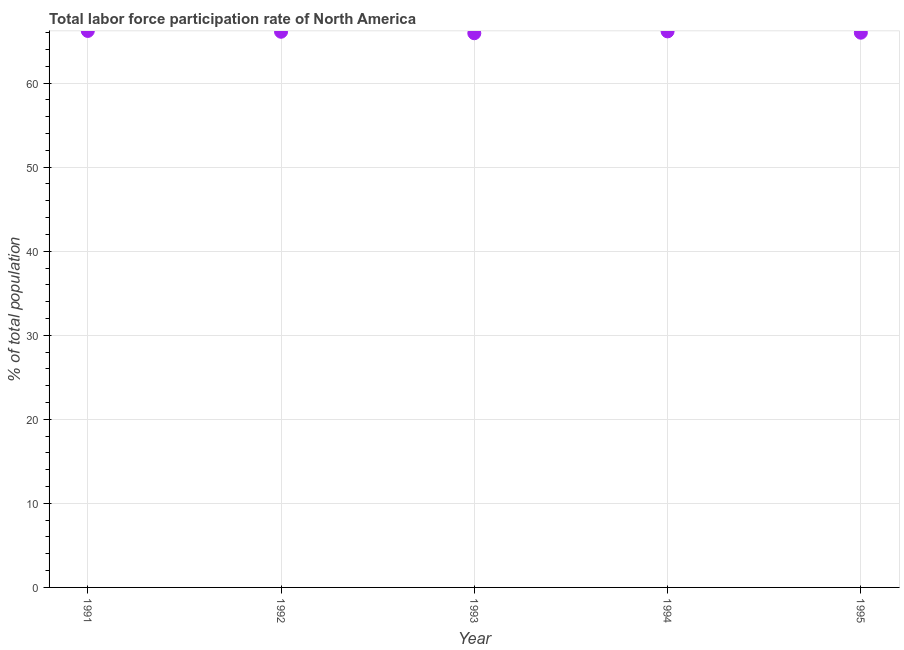What is the total labor force participation rate in 1994?
Provide a short and direct response. 66.15. Across all years, what is the maximum total labor force participation rate?
Your response must be concise. 66.21. Across all years, what is the minimum total labor force participation rate?
Ensure brevity in your answer.  65.93. In which year was the total labor force participation rate minimum?
Offer a terse response. 1993. What is the sum of the total labor force participation rate?
Ensure brevity in your answer.  330.4. What is the difference between the total labor force participation rate in 1991 and 1992?
Offer a very short reply. 0.1. What is the average total labor force participation rate per year?
Your answer should be compact. 66.08. What is the median total labor force participation rate?
Keep it short and to the point. 66.11. In how many years, is the total labor force participation rate greater than 12 %?
Provide a short and direct response. 5. Do a majority of the years between 1993 and 1994 (inclusive) have total labor force participation rate greater than 58 %?
Provide a succinct answer. Yes. What is the ratio of the total labor force participation rate in 1994 to that in 1995?
Your answer should be very brief. 1. What is the difference between the highest and the second highest total labor force participation rate?
Your answer should be compact. 0.05. Is the sum of the total labor force participation rate in 1991 and 1995 greater than the maximum total labor force participation rate across all years?
Keep it short and to the point. Yes. What is the difference between the highest and the lowest total labor force participation rate?
Offer a very short reply. 0.27. In how many years, is the total labor force participation rate greater than the average total labor force participation rate taken over all years?
Offer a terse response. 3. How many dotlines are there?
Provide a succinct answer. 1. What is the difference between two consecutive major ticks on the Y-axis?
Your answer should be very brief. 10. Does the graph contain any zero values?
Keep it short and to the point. No. What is the title of the graph?
Your answer should be compact. Total labor force participation rate of North America. What is the label or title of the Y-axis?
Give a very brief answer. % of total population. What is the % of total population in 1991?
Your response must be concise. 66.21. What is the % of total population in 1992?
Make the answer very short. 66.11. What is the % of total population in 1993?
Offer a terse response. 65.93. What is the % of total population in 1994?
Your response must be concise. 66.15. What is the % of total population in 1995?
Keep it short and to the point. 66. What is the difference between the % of total population in 1991 and 1992?
Provide a short and direct response. 0.1. What is the difference between the % of total population in 1991 and 1993?
Give a very brief answer. 0.27. What is the difference between the % of total population in 1991 and 1994?
Keep it short and to the point. 0.05. What is the difference between the % of total population in 1991 and 1995?
Your response must be concise. 0.21. What is the difference between the % of total population in 1992 and 1993?
Ensure brevity in your answer.  0.18. What is the difference between the % of total population in 1992 and 1994?
Your answer should be compact. -0.05. What is the difference between the % of total population in 1992 and 1995?
Provide a short and direct response. 0.11. What is the difference between the % of total population in 1993 and 1994?
Offer a very short reply. -0.22. What is the difference between the % of total population in 1993 and 1995?
Give a very brief answer. -0.06. What is the difference between the % of total population in 1994 and 1995?
Your answer should be compact. 0.16. What is the ratio of the % of total population in 1991 to that in 1992?
Give a very brief answer. 1. What is the ratio of the % of total population in 1991 to that in 1993?
Ensure brevity in your answer.  1. What is the ratio of the % of total population in 1991 to that in 1995?
Ensure brevity in your answer.  1. What is the ratio of the % of total population in 1992 to that in 1993?
Your answer should be compact. 1. What is the ratio of the % of total population in 1993 to that in 1994?
Give a very brief answer. 1. 